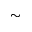Convert formula to latex. <formula><loc_0><loc_0><loc_500><loc_500>\sim</formula> 